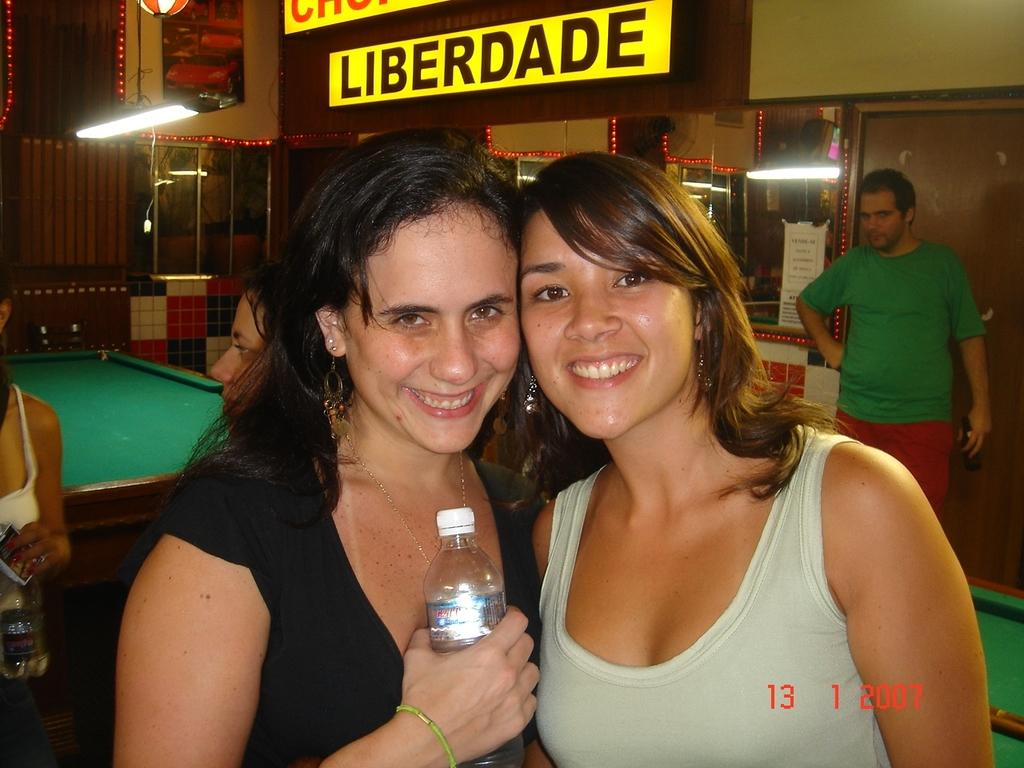How many women are in the image? There are two women in the image. What expressions do the women have? Both women are smiling. What is one of the women holding in her hand? One of the women is holding a bottle in her hand. What can be seen in the background of the image? There are people, lights, a wall, a door, and snooker tables visible in the background. How many frogs are present on the snooker tables in the image? There are no frogs present on the snooker tables in the image. What decision did the women make before the image was taken? The provided facts do not give any information about a decision made by the women, so it cannot be determined from the image. 